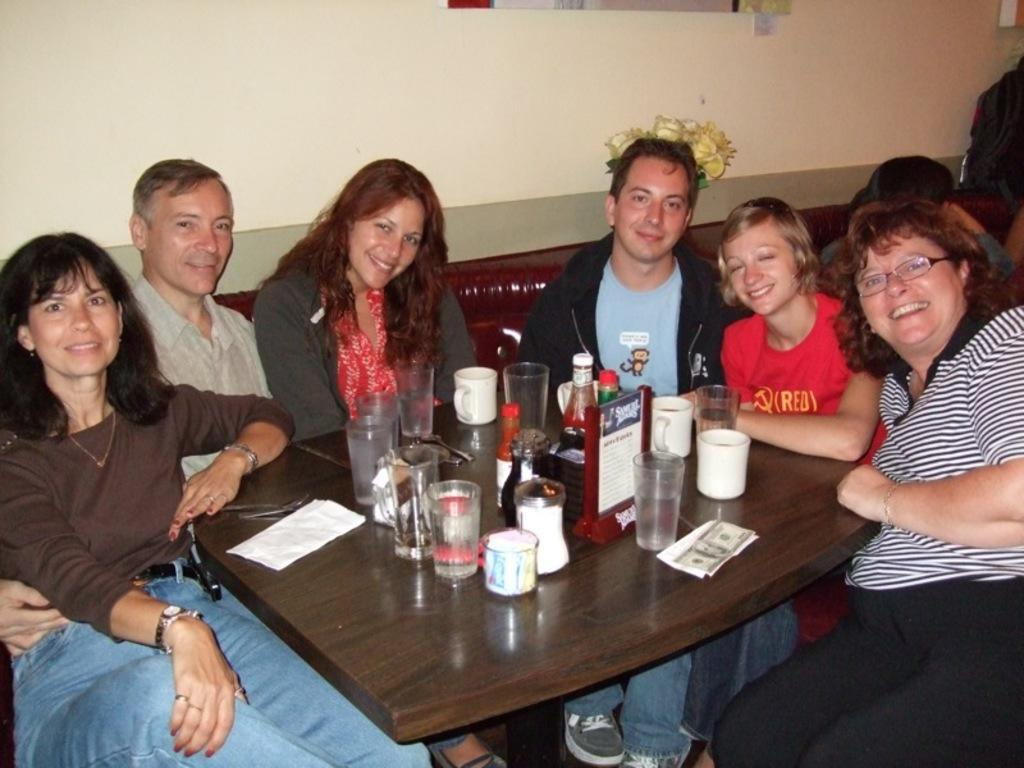How many people are in the image? There are six people in the image, four women and two men. What are the people doing in the image? The people are sitting. What objects can be seen on the table in the image? There are glasses, a bottle, and a paper on the table. What can be seen in the background of the image? There is a flower pot and a wall in the background. How many frames are hanging on the wall in the image? There are no frames visible in the image. 